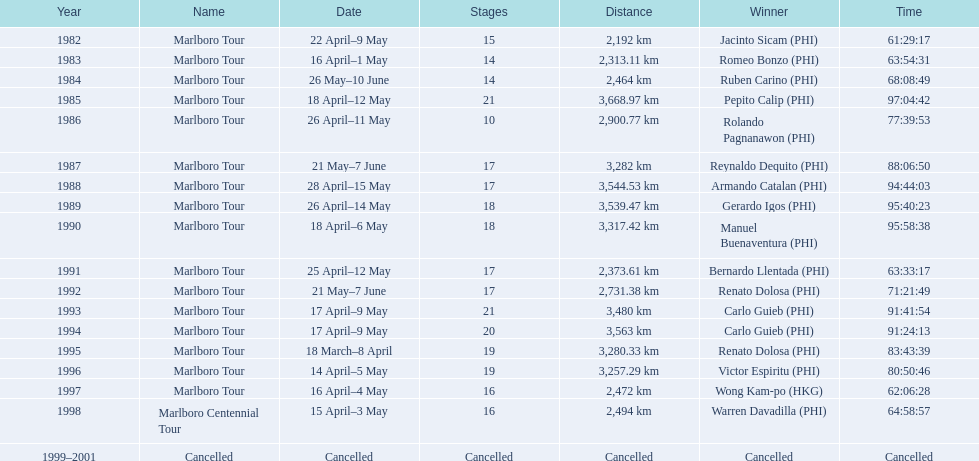Which race was warren davadilla involved in during 1998? Marlboro Centennial Tour. What duration did it take for davadilla to conclude the marlboro centennial tour? 64:58:57. 